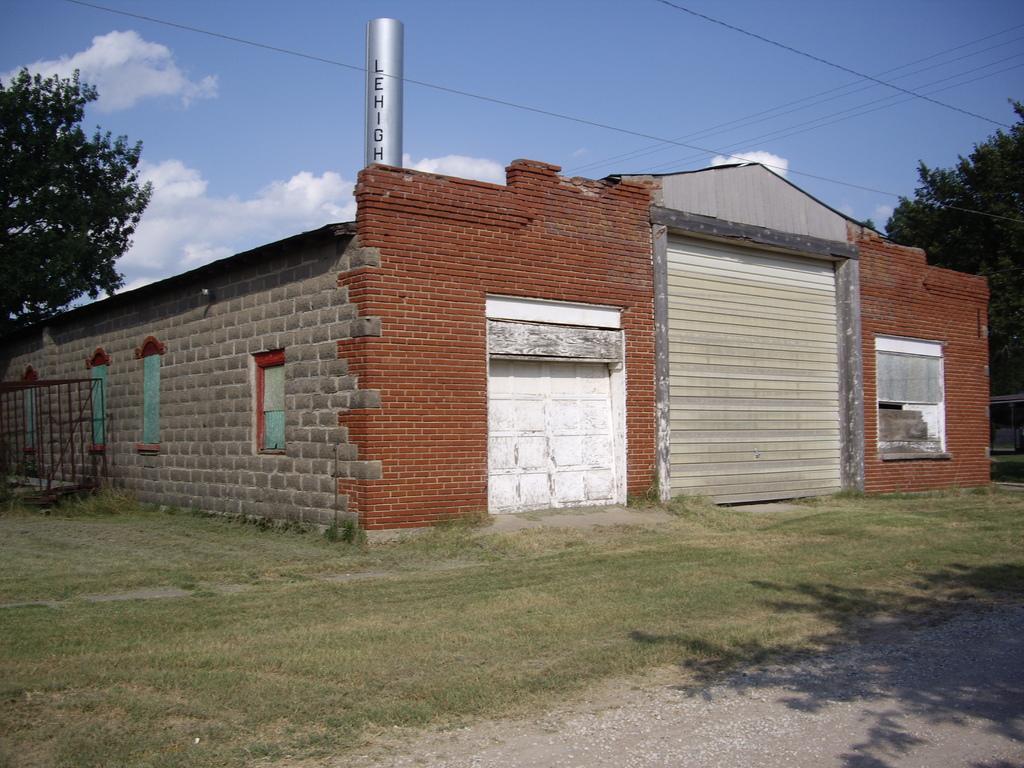Describe this image in one or two sentences. In the foreground of the picture of there are stones, path and grass. In the center of the picture there is a building, trees, windows, gate and brick wall. At the top there are cables. Sky is clear and it is sunny. 